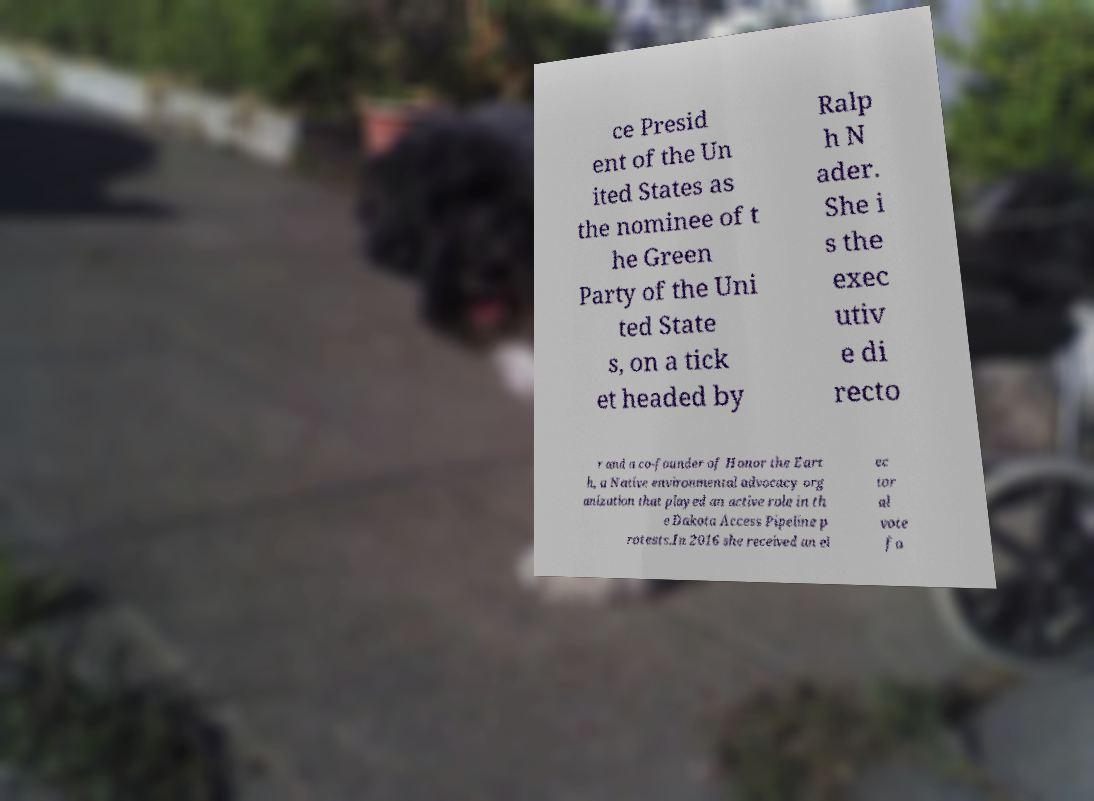There's text embedded in this image that I need extracted. Can you transcribe it verbatim? ce Presid ent of the Un ited States as the nominee of t he Green Party of the Uni ted State s, on a tick et headed by Ralp h N ader. She i s the exec utiv e di recto r and a co-founder of Honor the Eart h, a Native environmental advocacy org anization that played an active role in th e Dakota Access Pipeline p rotests.In 2016 she received an el ec tor al vote fo 